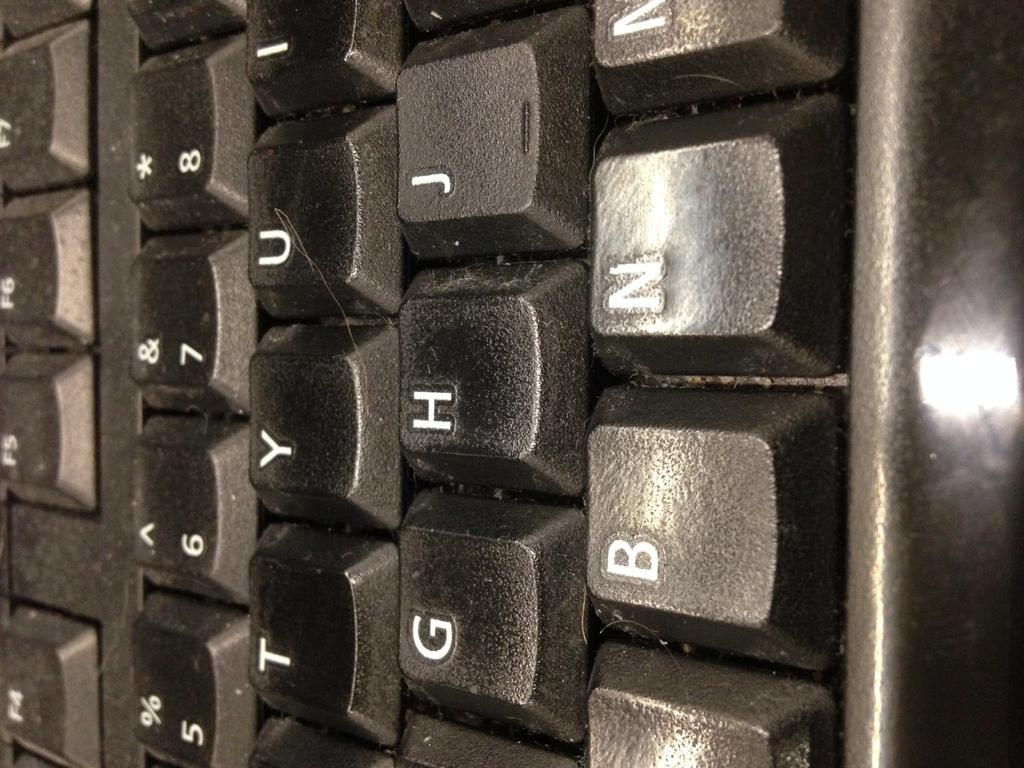<image>
Offer a succinct explanation of the picture presented. a close up of a black keyboard with keys G and H shown 